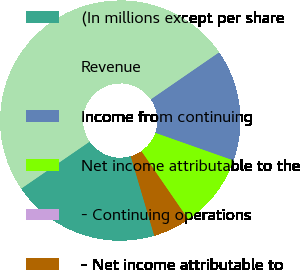Convert chart to OTSL. <chart><loc_0><loc_0><loc_500><loc_500><pie_chart><fcel>(In millions except per share<fcel>Revenue<fcel>Income from continuing<fcel>Net income attributable to the<fcel>- Continuing operations<fcel>- Net income attributable to<nl><fcel>20.0%<fcel>49.98%<fcel>15.0%<fcel>10.0%<fcel>0.01%<fcel>5.01%<nl></chart> 